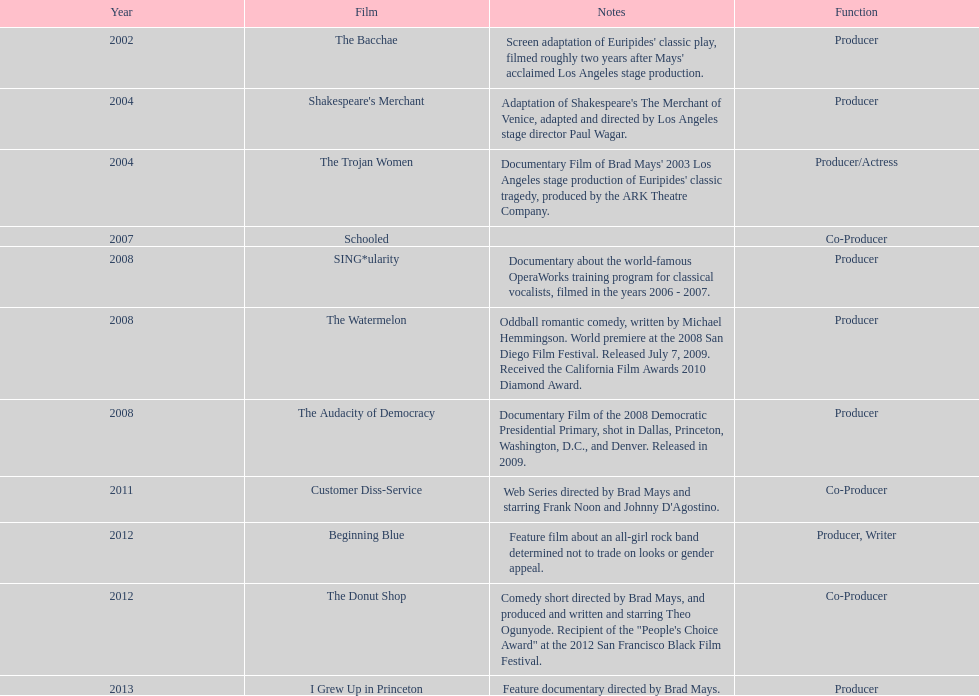How long was the film schooled out before beginning blue? 5 years. 